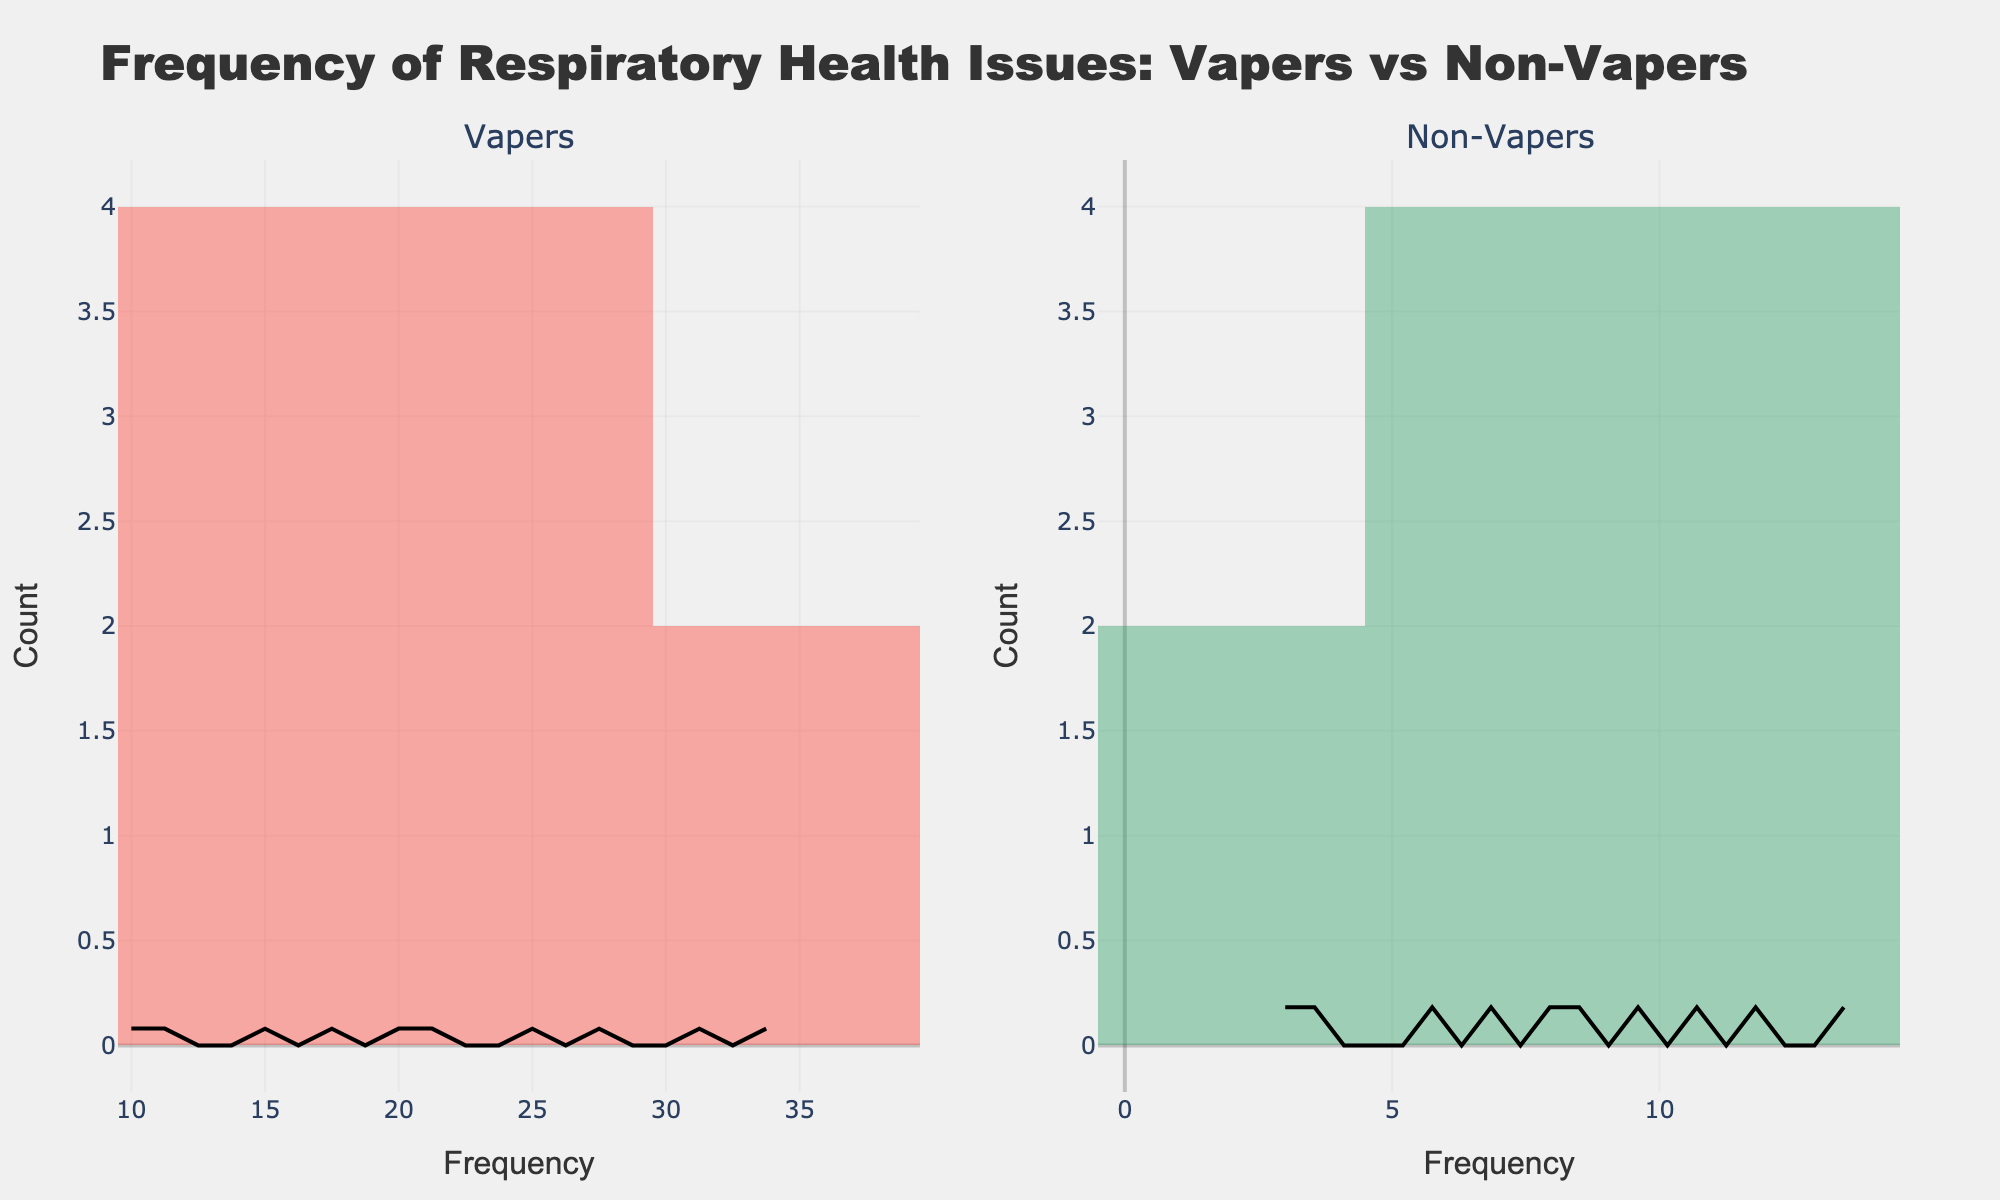What is the title of the figure? The title is usually prominently displayed at the top of the graph.
Answer: Frequency of Respiratory Health Issues: Vapers vs Non-Vapers Which group has a higher frequency of chronic cough? From the histogram bars, we can observe the height of the bars representing chronic cough for both groups. The vapers' bar is taller than the non-vapers'.
Answer: Vapers How many respiratory health issues have vapers reported frequencies greater than 25? Count the bars in the vapers' histogram that are greater than the 25 frequency mark. These issues are chronic cough, throat irritation, and shortness of breath.
Answer: 3 What is the difference in frequency for throat irritation between vapers and non-vapers? Find the bar representing throat irritation in both histograms and subtract the non-vapers' frequency from the vapers'. Throat irritation frequencies are 35 for vapers and 10 for non-vapers. 35 - 10 = 25.
Answer: 25 For which respiratory issue is the reported frequency similar between vapers and non-vapers? Compare the height of bars for both groups to find those that are close in height. Sinus problems show similar frequencies for both groups.
Answer: Sinus problems Which respiratory issue reported by vapers has the highest frequency? Look for the tallest bar in the vapers' histogram.
Answer: Throat irritation How many respiratory health issues have non-vapers reported more than 10 times? Count the bars in the non-vapers' histogram that exceed the 10 frequency mark and identify the issues. These are chronic cough, shortness of breath, and sinus problems.
Answer: 3 Which group has a higher median frequency of respiratory health issues reported? Determine the median value for each group by arranging the frequencies in order and finding the middle value. For vapers, arrange: 10, 12, 15, 18, 20, 22, 25, 28, 32, 35 and median is (20 + 22)/2 = 21. For non-vapers, arrange: 3, 4, 6, 7, 8, 9, 10, 11, 12, 14 and median is (9 + 10)/2 = 9.5.
Answer: Vapers What is the range of frequencies for COPD symptoms among both groups? Identify the heights of the bars representing COPD symptoms for both groups. For vapers, it is 12 and for non-vapers, it is 3.
Answer: 3 to 12 Which respiratory issue shows the least frequency reported by vapers? Identify the shortest bar in the vapers' histogram.
Answer: Pneumonia 